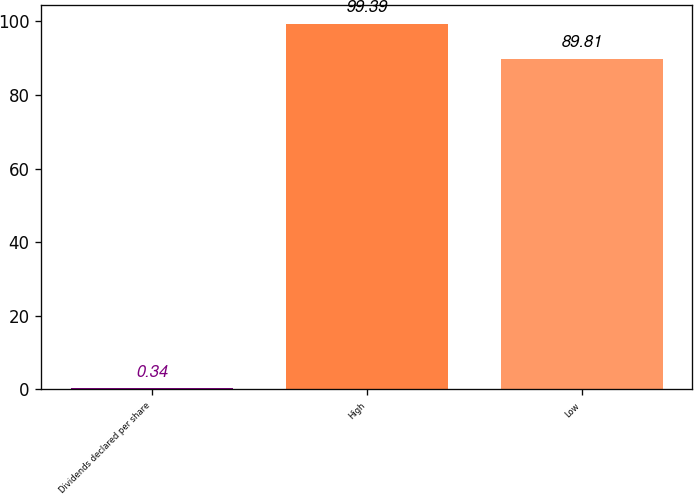Convert chart. <chart><loc_0><loc_0><loc_500><loc_500><bar_chart><fcel>Dividends declared per share<fcel>High<fcel>Low<nl><fcel>0.34<fcel>99.39<fcel>89.81<nl></chart> 